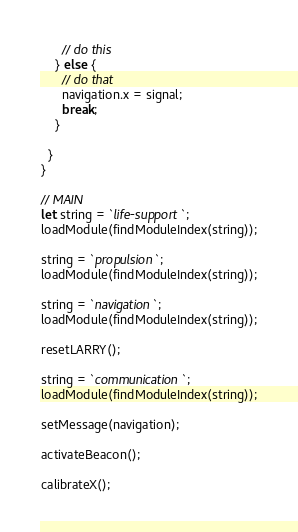<code> <loc_0><loc_0><loc_500><loc_500><_JavaScript_>      // do this
    } else {
      // do that
      navigation.x = signal;
      break;
    }

  }
}

// MAIN
let string = `life-support`;
loadModule(findModuleIndex(string));

string = `propulsion`;
loadModule(findModuleIndex(string));

string = `navigation`;
loadModule(findModuleIndex(string));

resetLARRY();

string = `communication`;
loadModule(findModuleIndex(string));

setMessage(navigation);

activateBeacon();

calibrateX();
</code> 